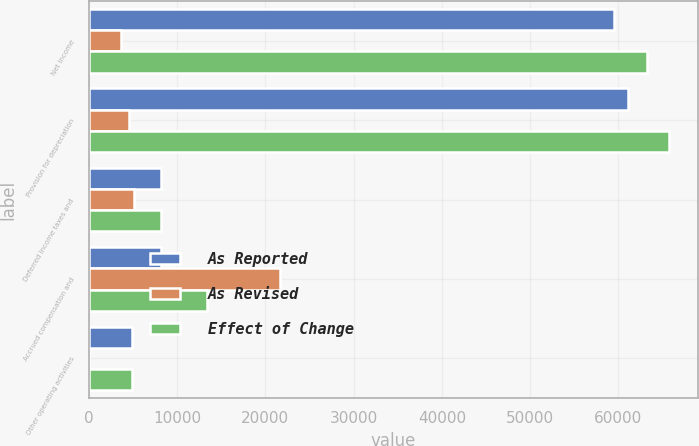Convert chart. <chart><loc_0><loc_0><loc_500><loc_500><stacked_bar_chart><ecel><fcel>Net income<fcel>Provision for depreciation<fcel>Deferred income taxes and<fcel>Accrued compensation and<fcel>Other operating activities<nl><fcel>As Reported<fcel>59492<fcel>61141<fcel>8206<fcel>8206<fcel>4909<nl><fcel>As Revised<fcel>3698<fcel>4553<fcel>5167<fcel>21648<fcel>49<nl><fcel>Effect of Change<fcel>63190<fcel>65694<fcel>8206<fcel>13442<fcel>4860<nl></chart> 